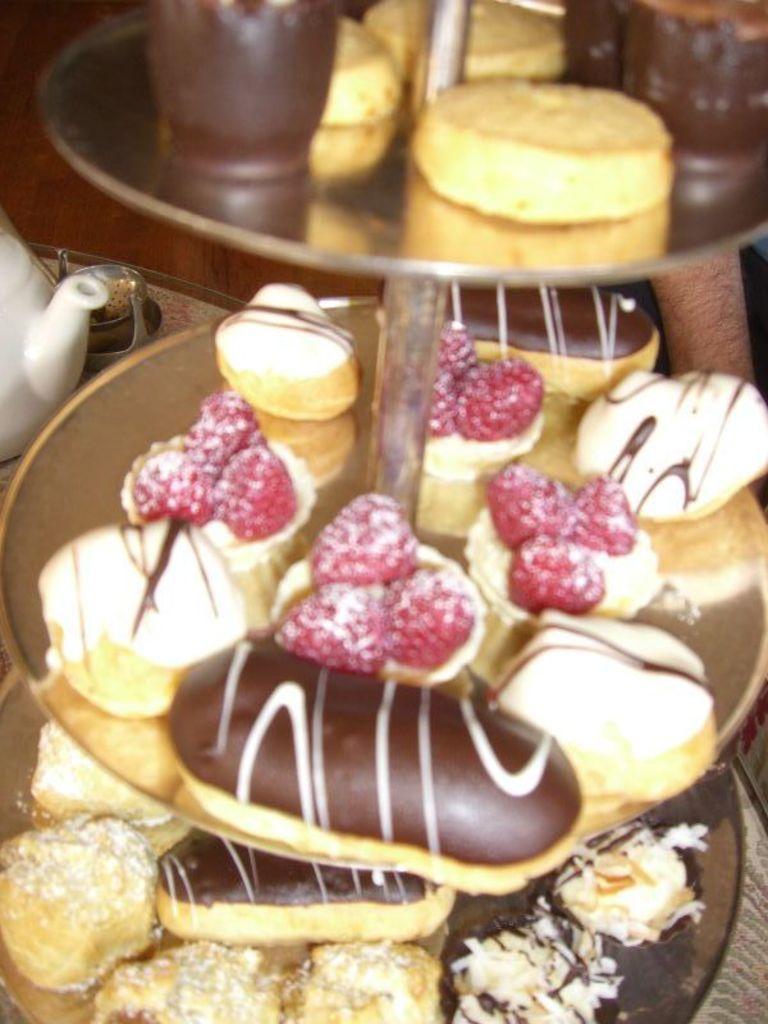Could you give a brief overview of what you see in this image? In this image I can see doughnuts, cake molds, fruits, cookies on a cake stand. In the background I can see a kettle and some objects. This image is taken may be in a restaurant. 